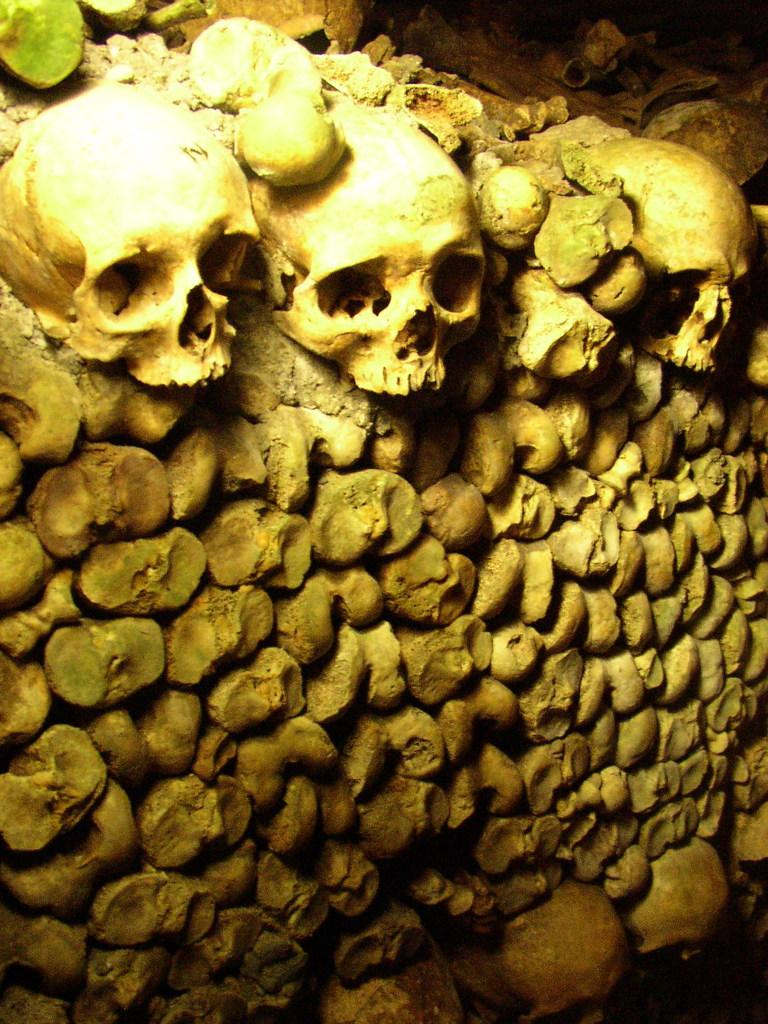What location is depicted in the image? The image depicts the Catacombs of Paris. Paris. What type of objects can be seen in the image? There are skulls in the image. Are there any objects visible at the top of the image? Yes, there are objects at the top of the image. What type of stove can be seen in the image? There is no stove present in the image. What knowledge is being shared in the image? The image does not depict any knowledge being shared; it shows the Catacombs of Paris with skulls and objects at the top. 